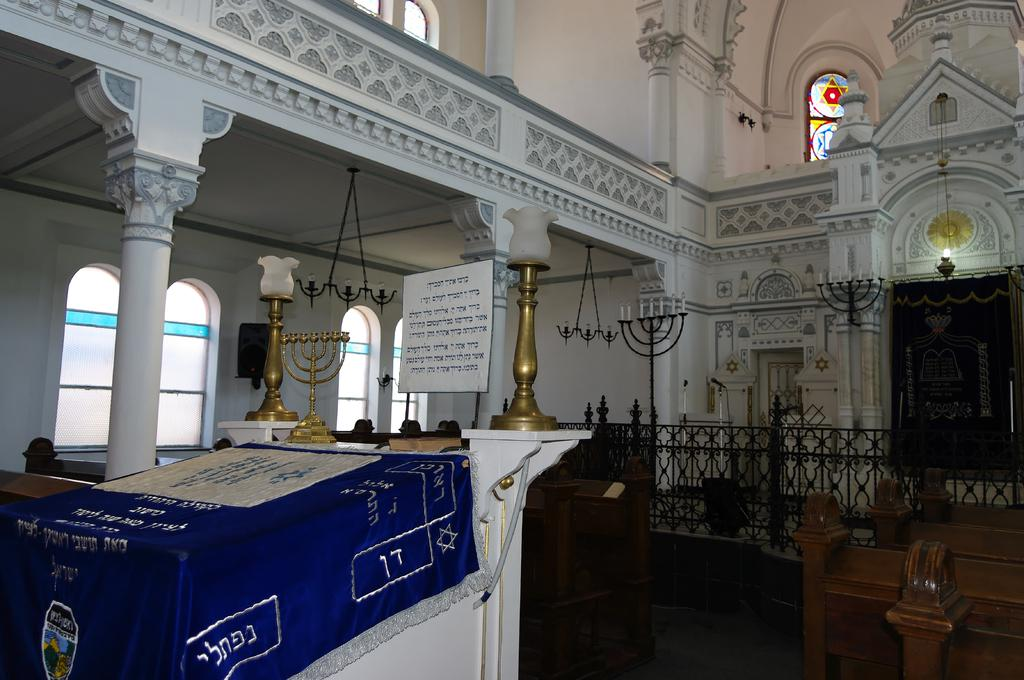What type of illumination is present in the image? There are lights in the image. Where is the door located in the image? The door is on the right side of the image. What is the purpose of the candle stand in the image? The candle stand is likely used for holding candles and providing additional light. What can be seen at the top of the image? There are windows visible at the top of the image. Can you see a rabbit combing its fur in the image? There is no rabbit or comb present in the image. 